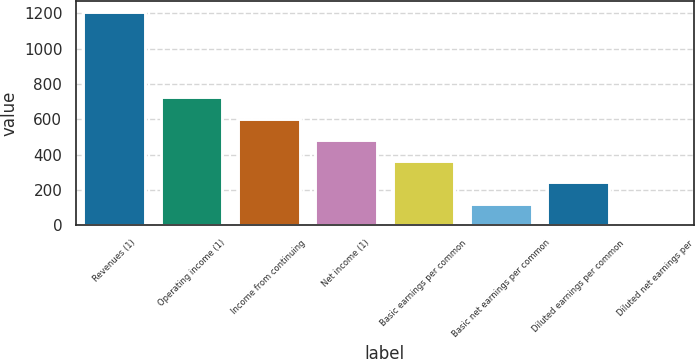Convert chart. <chart><loc_0><loc_0><loc_500><loc_500><bar_chart><fcel>Revenues (1)<fcel>Operating income (1)<fcel>Income from continuing<fcel>Net income (1)<fcel>Basic earnings per common<fcel>Basic net earnings per common<fcel>Diluted earnings per common<fcel>Diluted net earnings per<nl><fcel>1207<fcel>724.29<fcel>603.61<fcel>482.93<fcel>362.25<fcel>120.89<fcel>241.57<fcel>0.21<nl></chart> 